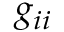<formula> <loc_0><loc_0><loc_500><loc_500>g _ { i i }</formula> 